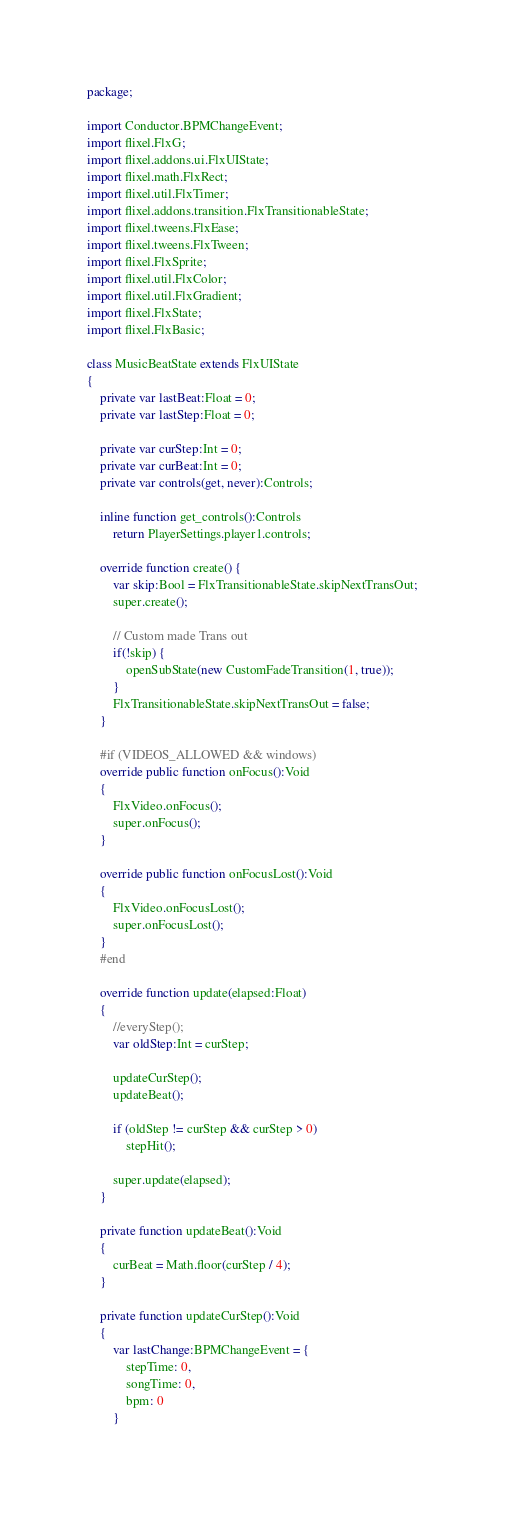Convert code to text. <code><loc_0><loc_0><loc_500><loc_500><_Haxe_>package;

import Conductor.BPMChangeEvent;
import flixel.FlxG;
import flixel.addons.ui.FlxUIState;
import flixel.math.FlxRect;
import flixel.util.FlxTimer;
import flixel.addons.transition.FlxTransitionableState;
import flixel.tweens.FlxEase;
import flixel.tweens.FlxTween;
import flixel.FlxSprite;
import flixel.util.FlxColor;
import flixel.util.FlxGradient;
import flixel.FlxState;
import flixel.FlxBasic;

class MusicBeatState extends FlxUIState
{
	private var lastBeat:Float = 0;
	private var lastStep:Float = 0;

	private var curStep:Int = 0;
	private var curBeat:Int = 0;
	private var controls(get, never):Controls;

	inline function get_controls():Controls
		return PlayerSettings.player1.controls;

	override function create() {
		var skip:Bool = FlxTransitionableState.skipNextTransOut;
		super.create();

		// Custom made Trans out
		if(!skip) {
			openSubState(new CustomFadeTransition(1, true));
		}
		FlxTransitionableState.skipNextTransOut = false;
	}
	
	#if (VIDEOS_ALLOWED && windows)
	override public function onFocus():Void
	{
		FlxVideo.onFocus();
		super.onFocus();
	}
	
	override public function onFocusLost():Void
	{
		FlxVideo.onFocusLost();
		super.onFocusLost();
	}
	#end

	override function update(elapsed:Float)
	{
		//everyStep();
		var oldStep:Int = curStep;

		updateCurStep();
		updateBeat();

		if (oldStep != curStep && curStep > 0)
			stepHit();

		super.update(elapsed);
	}

	private function updateBeat():Void
	{
		curBeat = Math.floor(curStep / 4);
	}

	private function updateCurStep():Void
	{
		var lastChange:BPMChangeEvent = {
			stepTime: 0,
			songTime: 0,
			bpm: 0
		}</code> 